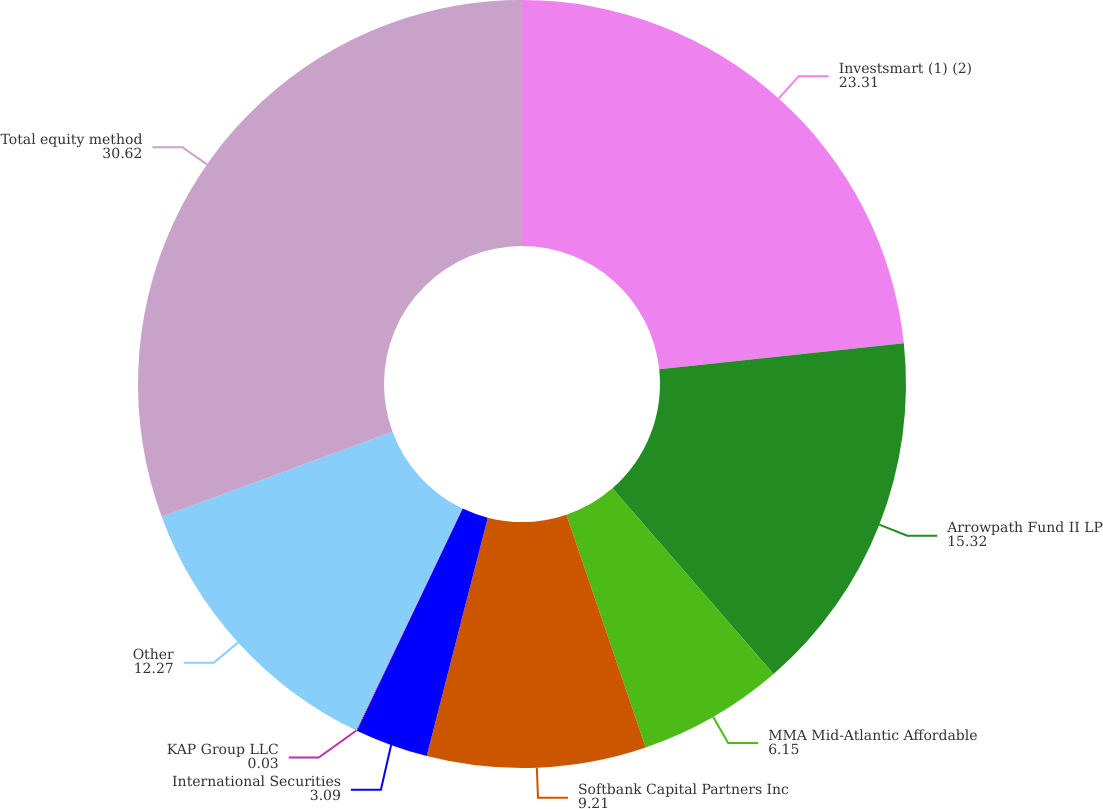Convert chart. <chart><loc_0><loc_0><loc_500><loc_500><pie_chart><fcel>Investsmart (1) (2)<fcel>Arrowpath Fund II LP<fcel>MMA Mid-Atlantic Affordable<fcel>Softbank Capital Partners Inc<fcel>International Securities<fcel>KAP Group LLC<fcel>Other<fcel>Total equity method<nl><fcel>23.31%<fcel>15.32%<fcel>6.15%<fcel>9.21%<fcel>3.09%<fcel>0.03%<fcel>12.27%<fcel>30.62%<nl></chart> 